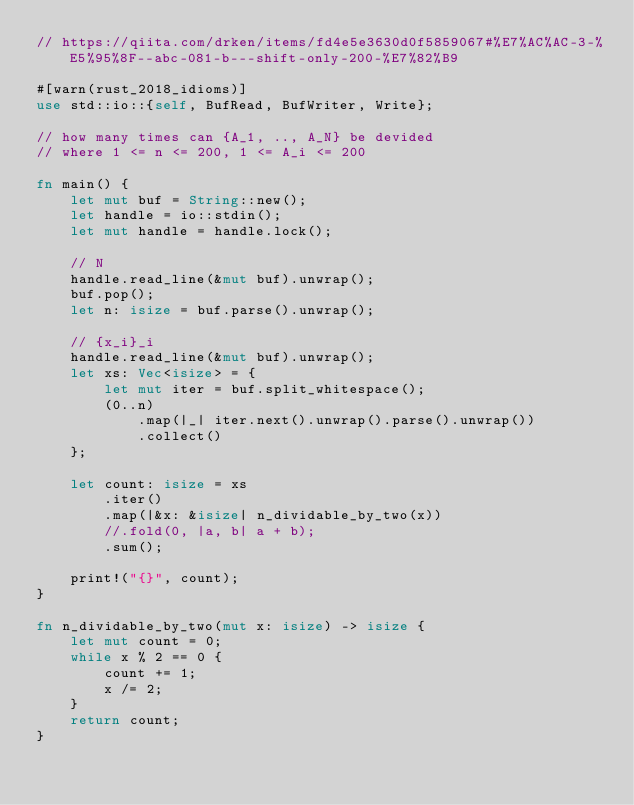Convert code to text. <code><loc_0><loc_0><loc_500><loc_500><_Rust_>// https://qiita.com/drken/items/fd4e5e3630d0f5859067#%E7%AC%AC-3-%E5%95%8F--abc-081-b---shift-only-200-%E7%82%B9

#[warn(rust_2018_idioms)]
use std::io::{self, BufRead, BufWriter, Write};

// how many times can {A_1, .., A_N} be devided
// where 1 <= n <= 200, 1 <= A_i <= 200

fn main() {
    let mut buf = String::new();
    let handle = io::stdin();
    let mut handle = handle.lock();

    // N
    handle.read_line(&mut buf).unwrap();
    buf.pop();
    let n: isize = buf.parse().unwrap();

    // {x_i}_i
    handle.read_line(&mut buf).unwrap();
    let xs: Vec<isize> = {
        let mut iter = buf.split_whitespace();
        (0..n)
            .map(|_| iter.next().unwrap().parse().unwrap())
            .collect()
    };

    let count: isize = xs
        .iter()
        .map(|&x: &isize| n_dividable_by_two(x))
        //.fold(0, |a, b| a + b);
        .sum();

    print!("{}", count);
}

fn n_dividable_by_two(mut x: isize) -> isize {
    let mut count = 0;
    while x % 2 == 0 {
        count += 1;
        x /= 2;
    }
    return count;
}
</code> 